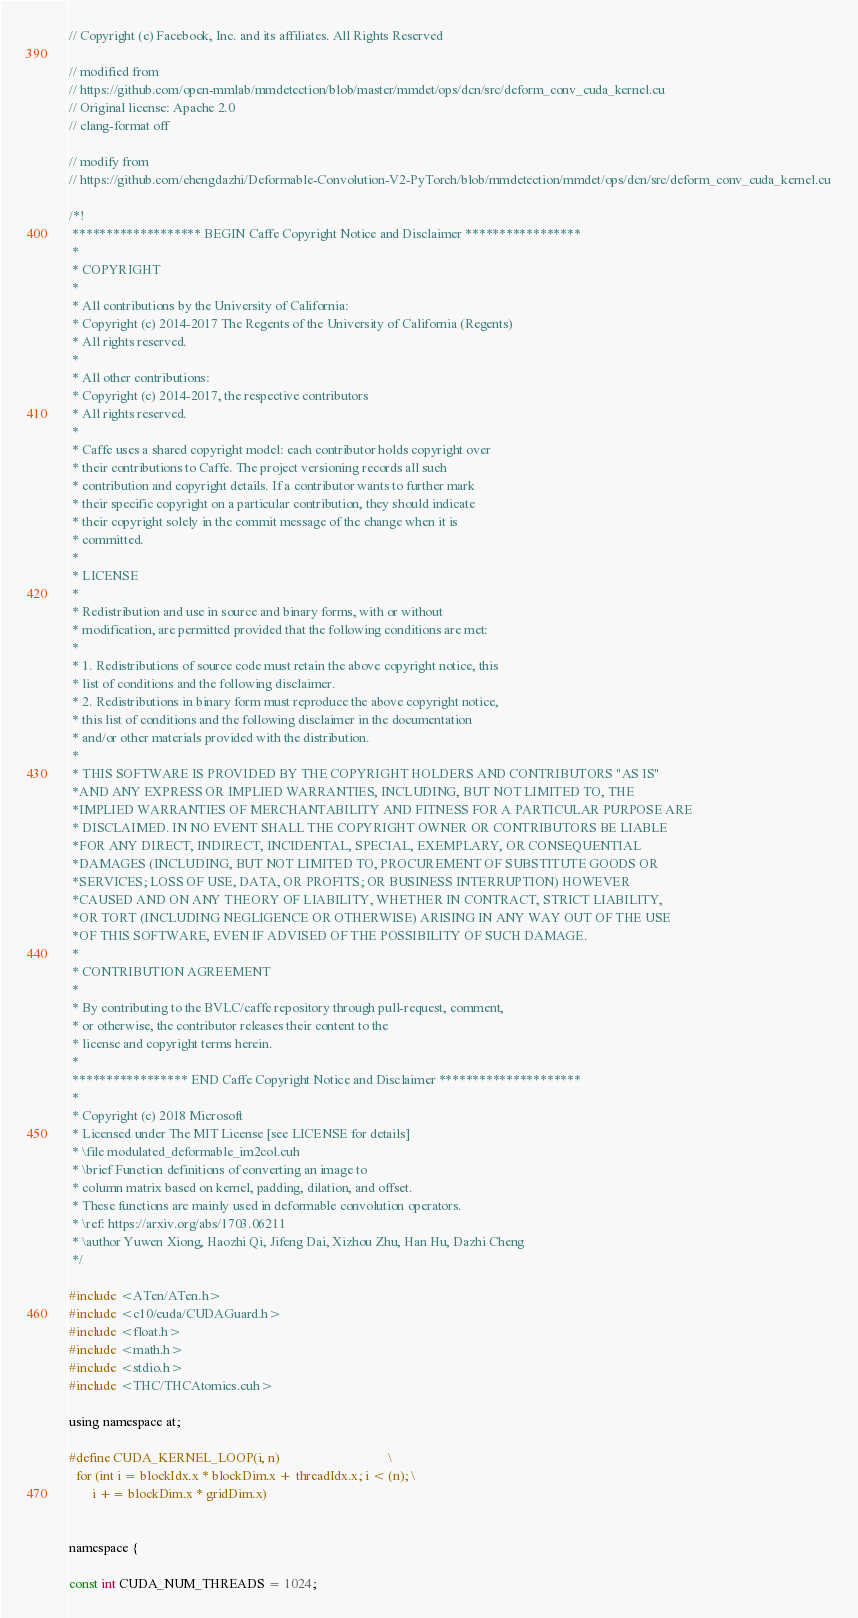<code> <loc_0><loc_0><loc_500><loc_500><_Cuda_>// Copyright (c) Facebook, Inc. and its affiliates. All Rights Reserved

// modified from
// https://github.com/open-mmlab/mmdetection/blob/master/mmdet/ops/dcn/src/deform_conv_cuda_kernel.cu
// Original license: Apache 2.0
// clang-format off

// modify from
// https://github.com/chengdazhi/Deformable-Convolution-V2-PyTorch/blob/mmdetection/mmdet/ops/dcn/src/deform_conv_cuda_kernel.cu

/*!
 ******************* BEGIN Caffe Copyright Notice and Disclaimer *****************
 *
 * COPYRIGHT
 *
 * All contributions by the University of California:
 * Copyright (c) 2014-2017 The Regents of the University of California (Regents)
 * All rights reserved.
 *
 * All other contributions:
 * Copyright (c) 2014-2017, the respective contributors
 * All rights reserved.
 *
 * Caffe uses a shared copyright model: each contributor holds copyright over
 * their contributions to Caffe. The project versioning records all such
 * contribution and copyright details. If a contributor wants to further mark
 * their specific copyright on a particular contribution, they should indicate
 * their copyright solely in the commit message of the change when it is
 * committed.
 *
 * LICENSE
 *
 * Redistribution and use in source and binary forms, with or without
 * modification, are permitted provided that the following conditions are met:
 *
 * 1. Redistributions of source code must retain the above copyright notice, this
 * list of conditions and the following disclaimer.
 * 2. Redistributions in binary form must reproduce the above copyright notice,
 * this list of conditions and the following disclaimer in the documentation
 * and/or other materials provided with the distribution.
 *
 * THIS SOFTWARE IS PROVIDED BY THE COPYRIGHT HOLDERS AND CONTRIBUTORS "AS IS"
 *AND ANY EXPRESS OR IMPLIED WARRANTIES, INCLUDING, BUT NOT LIMITED TO, THE
 *IMPLIED WARRANTIES OF MERCHANTABILITY AND FITNESS FOR A PARTICULAR PURPOSE ARE
 * DISCLAIMED. IN NO EVENT SHALL THE COPYRIGHT OWNER OR CONTRIBUTORS BE LIABLE
 *FOR ANY DIRECT, INDIRECT, INCIDENTAL, SPECIAL, EXEMPLARY, OR CONSEQUENTIAL
 *DAMAGES (INCLUDING, BUT NOT LIMITED TO, PROCUREMENT OF SUBSTITUTE GOODS OR
 *SERVICES; LOSS OF USE, DATA, OR PROFITS; OR BUSINESS INTERRUPTION) HOWEVER
 *CAUSED AND ON ANY THEORY OF LIABILITY, WHETHER IN CONTRACT, STRICT LIABILITY,
 *OR TORT (INCLUDING NEGLIGENCE OR OTHERWISE) ARISING IN ANY WAY OUT OF THE USE
 *OF THIS SOFTWARE, EVEN IF ADVISED OF THE POSSIBILITY OF SUCH DAMAGE.
 *
 * CONTRIBUTION AGREEMENT
 *
 * By contributing to the BVLC/caffe repository through pull-request, comment,
 * or otherwise, the contributor releases their content to the
 * license and copyright terms herein.
 *
 ***************** END Caffe Copyright Notice and Disclaimer *********************
 *
 * Copyright (c) 2018 Microsoft
 * Licensed under The MIT License [see LICENSE for details]
 * \file modulated_deformable_im2col.cuh
 * \brief Function definitions of converting an image to
 * column matrix based on kernel, padding, dilation, and offset.
 * These functions are mainly used in deformable convolution operators.
 * \ref: https://arxiv.org/abs/1703.06211
 * \author Yuwen Xiong, Haozhi Qi, Jifeng Dai, Xizhou Zhu, Han Hu, Dazhi Cheng
 */

#include <ATen/ATen.h>
#include <c10/cuda/CUDAGuard.h>
#include <float.h>
#include <math.h>
#include <stdio.h>
#include <THC/THCAtomics.cuh>

using namespace at;

#define CUDA_KERNEL_LOOP(i, n)                                 \
  for (int i = blockIdx.x * blockDim.x + threadIdx.x; i < (n); \
       i += blockDim.x * gridDim.x)


namespace {

const int CUDA_NUM_THREADS = 1024;</code> 